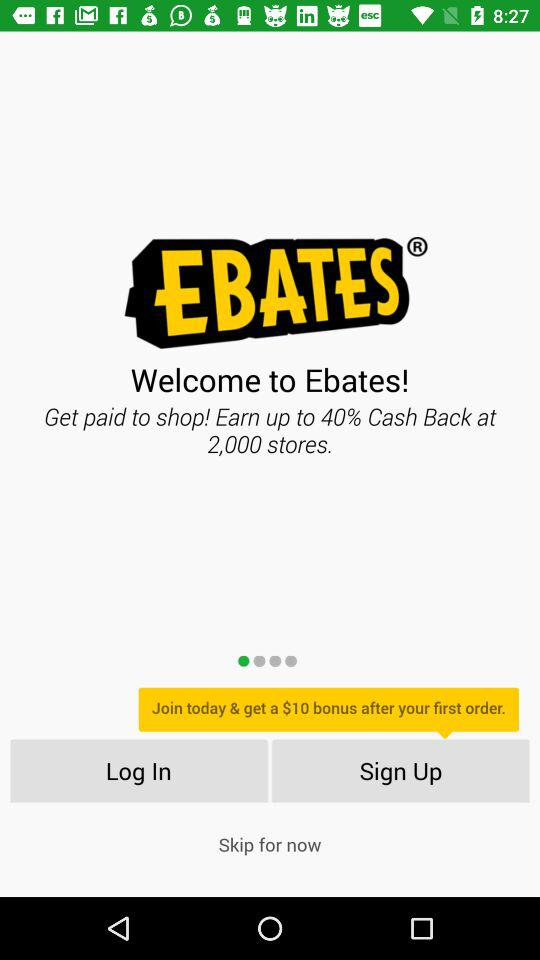What bonus amount will be received after the 1st order? The bonus amount that will be received after the 1st order is $10. 